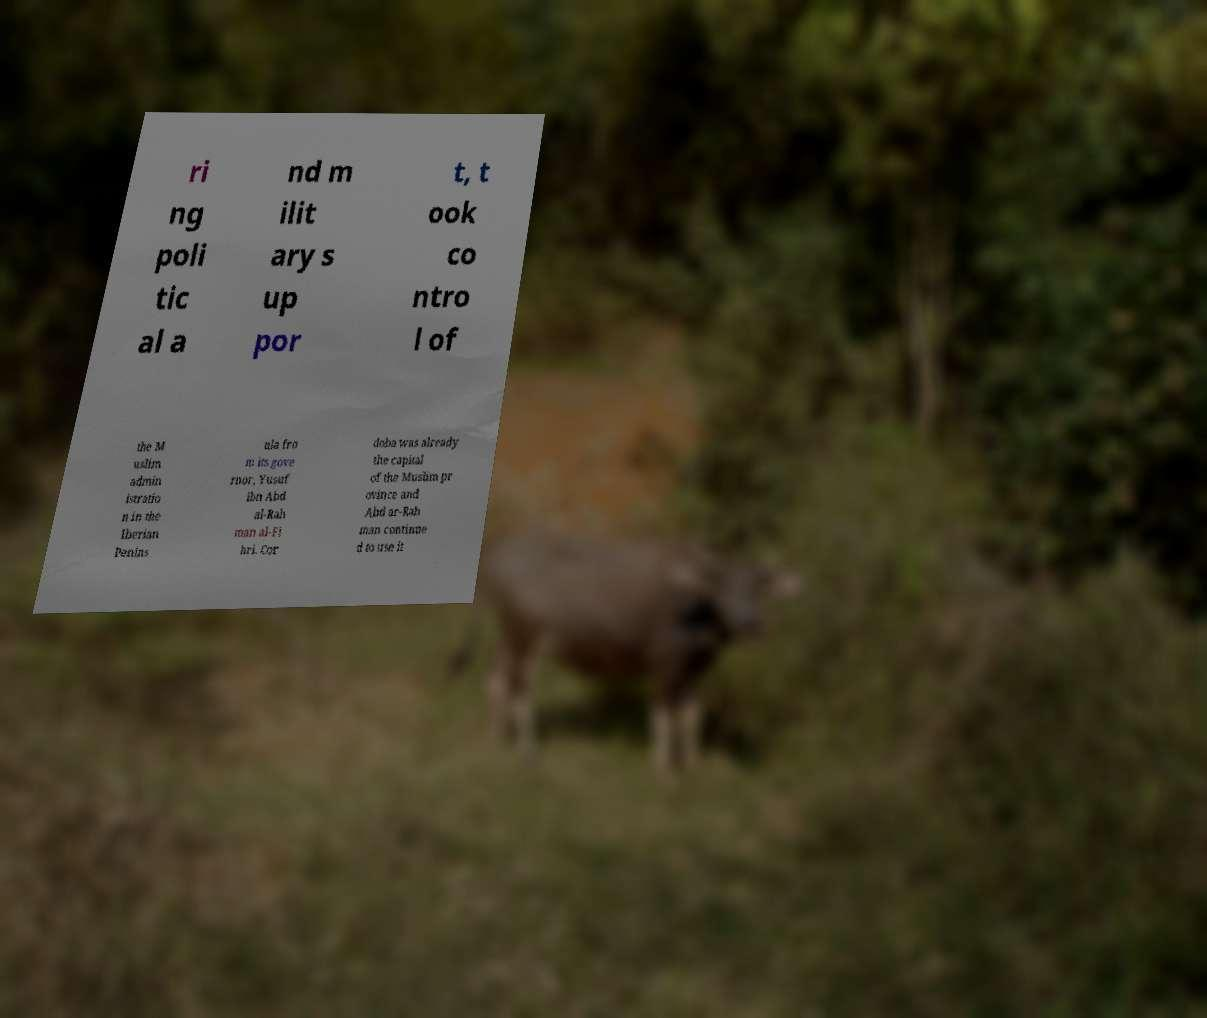I need the written content from this picture converted into text. Can you do that? ri ng poli tic al a nd m ilit ary s up por t, t ook co ntro l of the M uslim admin istratio n in the Iberian Penins ula fro m its gove rnor, Yusuf ibn Abd al-Rah man al-Fi hri. Cor doba was already the capital of the Muslim pr ovince and Abd ar-Rah man continue d to use it 